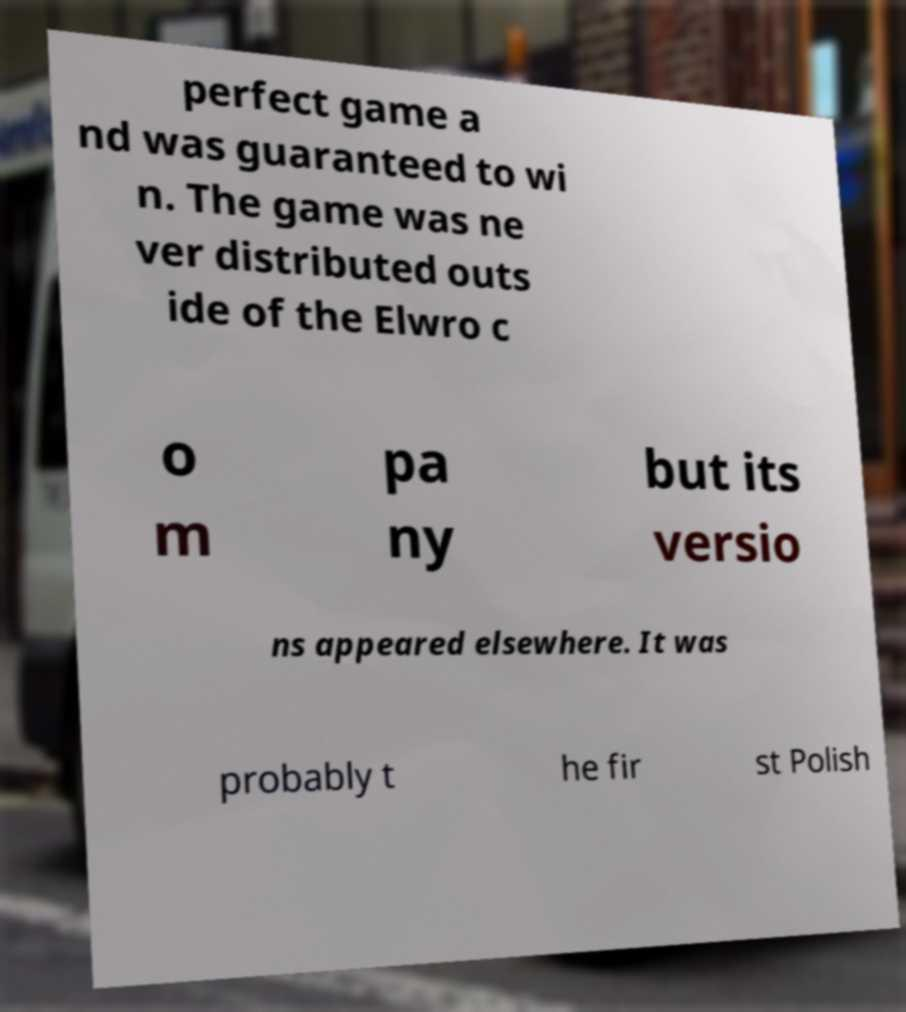There's text embedded in this image that I need extracted. Can you transcribe it verbatim? perfect game a nd was guaranteed to wi n. The game was ne ver distributed outs ide of the Elwro c o m pa ny but its versio ns appeared elsewhere. It was probably t he fir st Polish 